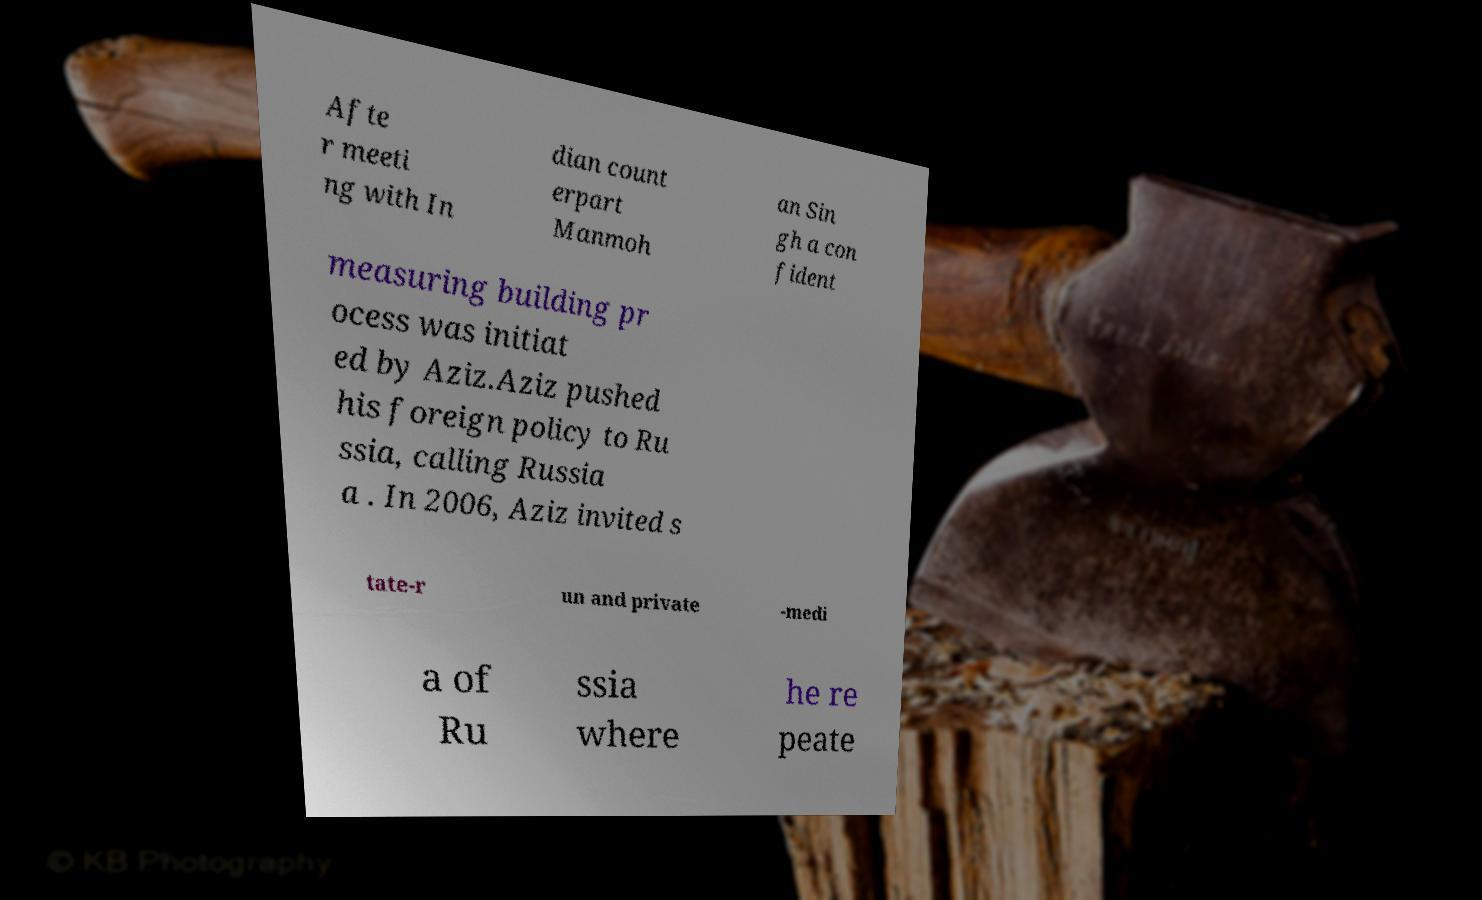What messages or text are displayed in this image? I need them in a readable, typed format. Afte r meeti ng with In dian count erpart Manmoh an Sin gh a con fident measuring building pr ocess was initiat ed by Aziz.Aziz pushed his foreign policy to Ru ssia, calling Russia a . In 2006, Aziz invited s tate-r un and private -medi a of Ru ssia where he re peate 